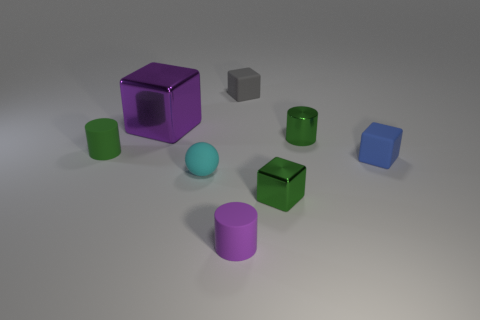Subtract all gray blocks. How many blocks are left? 3 Subtract all small gray cubes. How many cubes are left? 3 Subtract all yellow cubes. Subtract all gray spheres. How many cubes are left? 4 Add 1 tiny cyan matte spheres. How many objects exist? 9 Subtract all cylinders. How many objects are left? 5 Subtract all large brown shiny cylinders. Subtract all matte balls. How many objects are left? 7 Add 4 tiny gray cubes. How many tiny gray cubes are left? 5 Add 2 cyan objects. How many cyan objects exist? 3 Subtract 2 green cylinders. How many objects are left? 6 